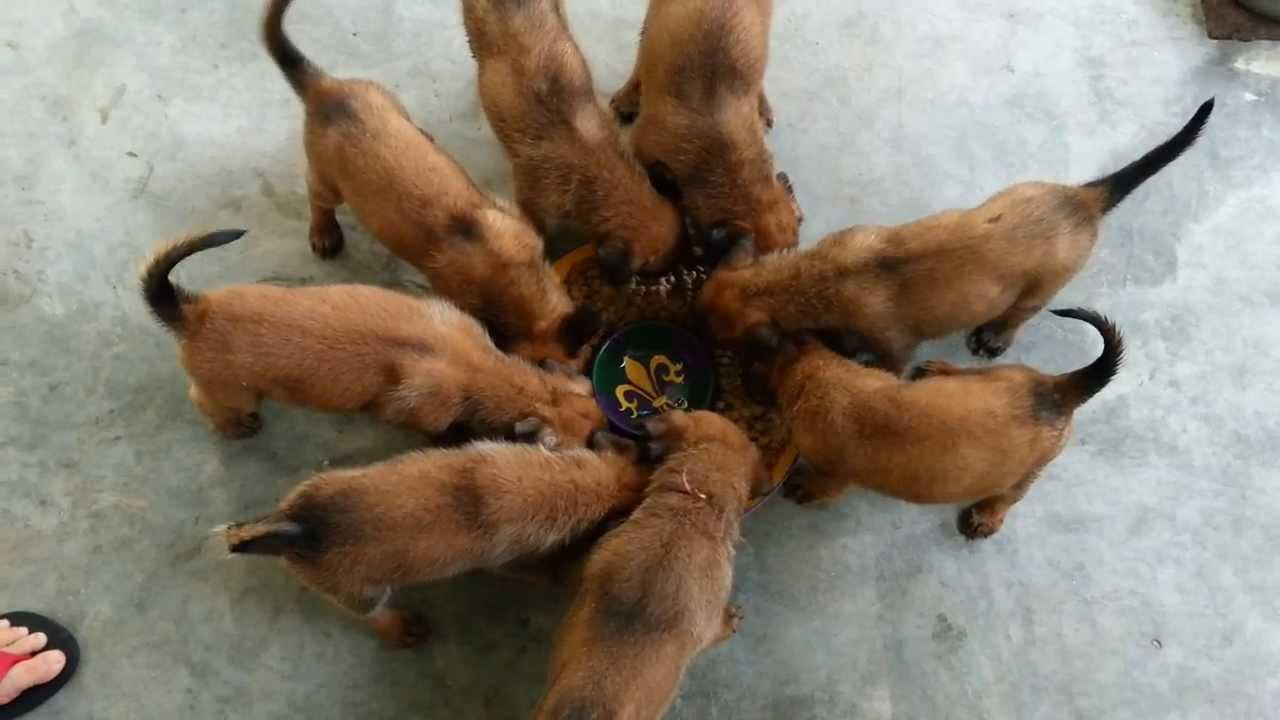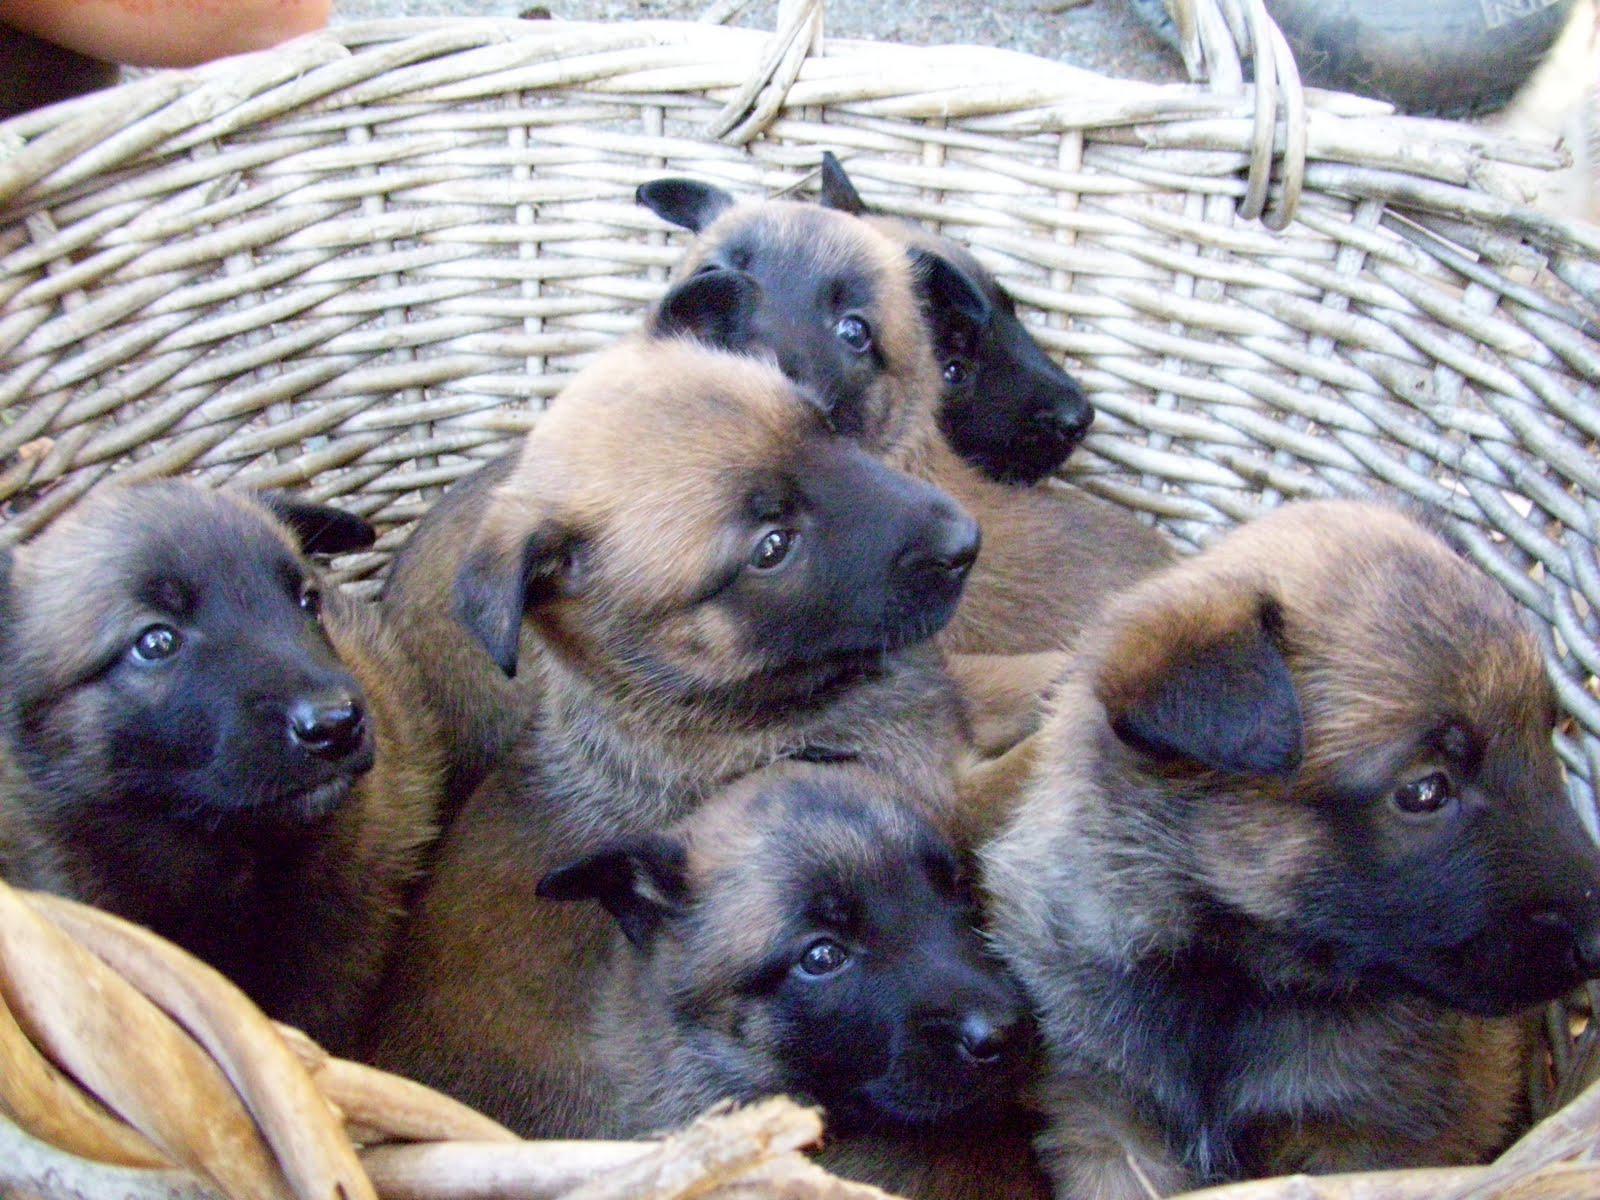The first image is the image on the left, the second image is the image on the right. Analyze the images presented: Is the assertion "Each image shows a pile of puppies, and at least one pile of puppies is surrounded by a wire enclosure." valid? Answer yes or no. No. The first image is the image on the left, the second image is the image on the right. Given the left and right images, does the statement "The puppies in at least one of the images are in a wired cage." hold true? Answer yes or no. No. 